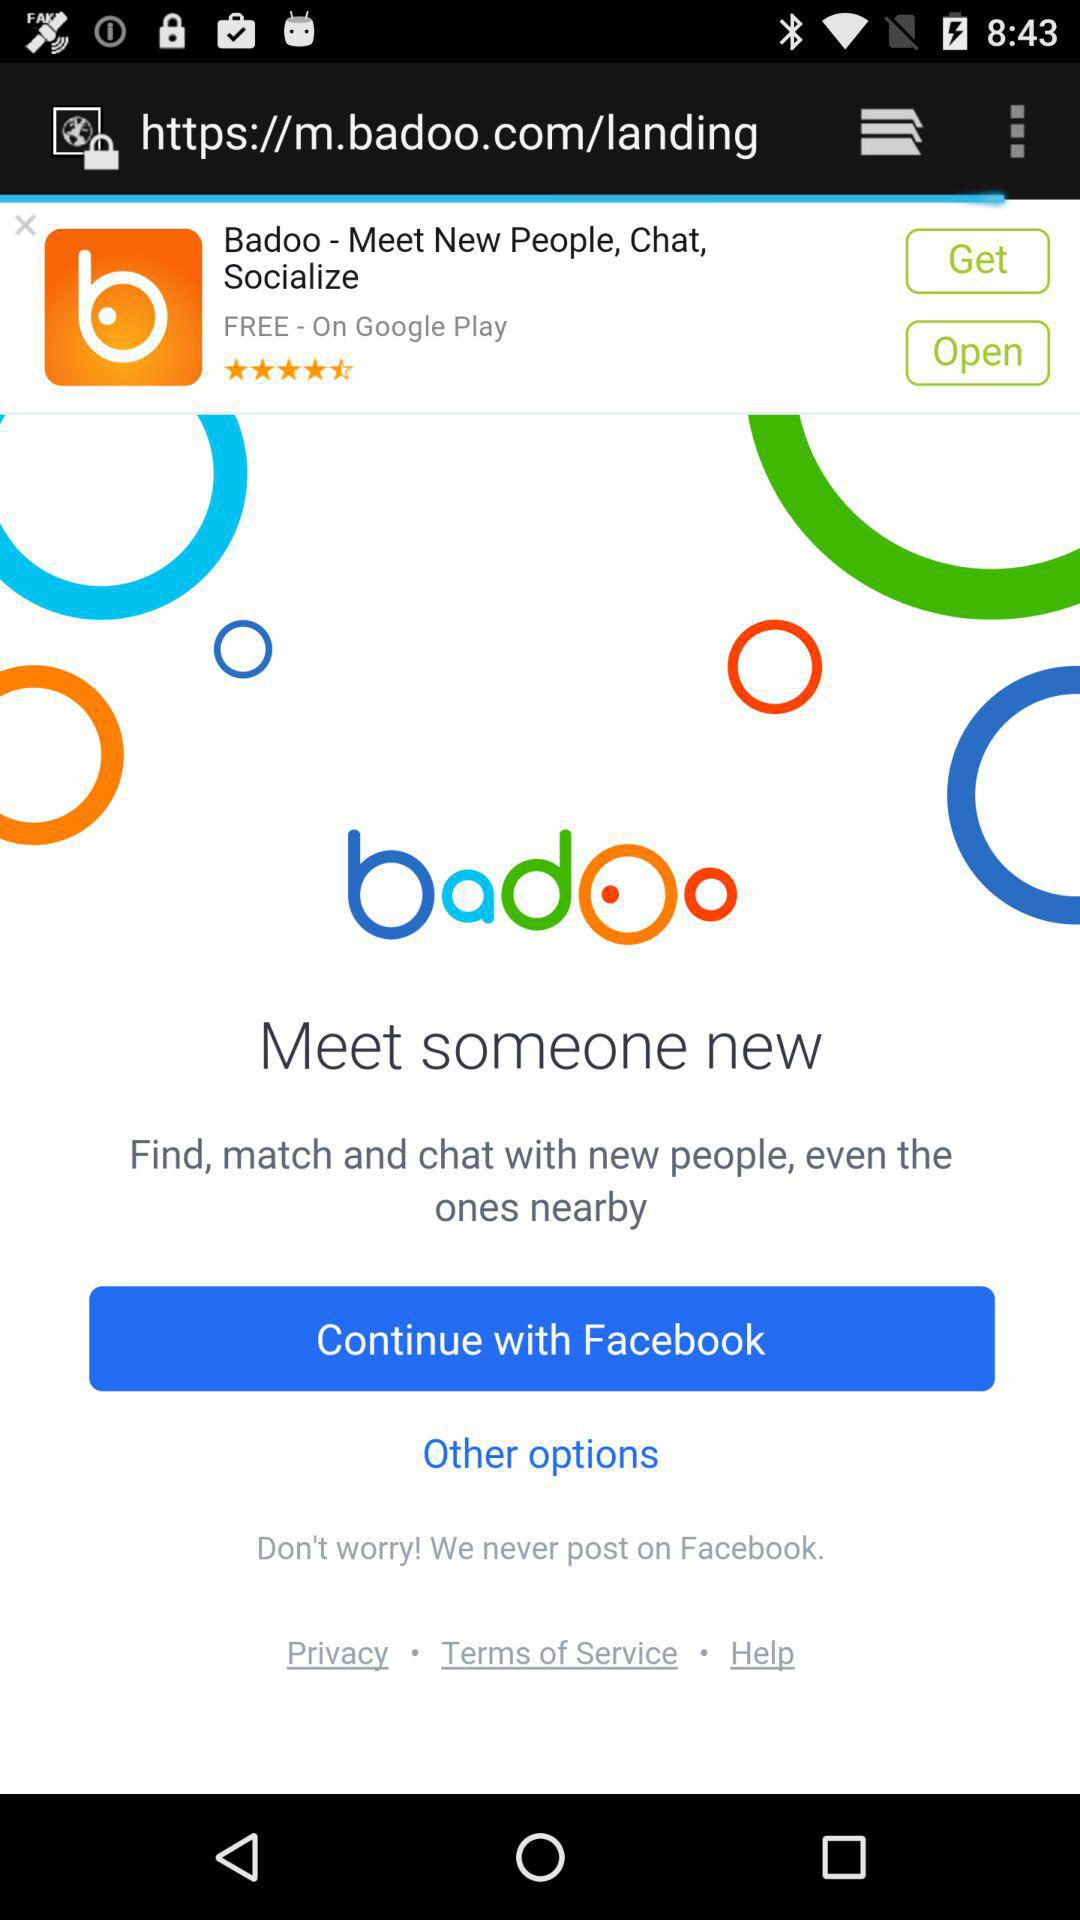What application is used to proceed? The application is "Facebook". 